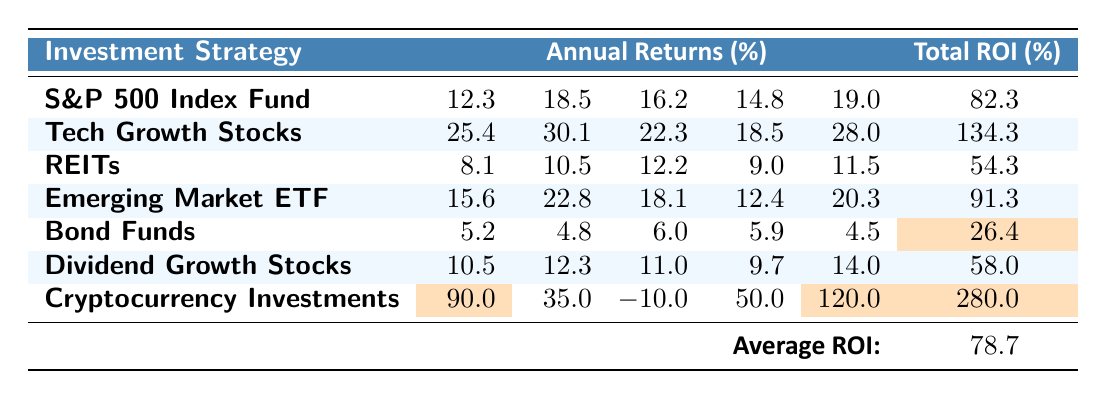What is the total ROI for Tech Growth Stocks? The table shows that the total ROI for Tech Growth Stocks is listed directly in the last column, next to the strategy, which is 134.3%.
Answer: 134.3% Which investment strategy has the highest total ROI? By examining the total ROI values in the last column, Cryptocurrency Investments has the highest ROI at 280.0%.
Answer: Cryptocurrency Investments What was the annual return for Bond Funds in the second year? The annual returns for Bond Funds are listed in the row corresponding to the strategy. The value for the second year is 4.8%.
Answer: 4.8% Calculate the average total ROI among the different strategies listed in the table. There are 7 strategies. The total ROIs are: 82.3, 134.3, 54.3, 91.3, 26.4, 58.0, and 280.0. Adding these gives a sum of 626.0. Dividing by 7 gives an average ROI of 89.42857, which rounds to 78.7 as noted in the summary.
Answer: 78.7 Is the ROI for Dividend Growth Stocks greater than 60%? Looking at the total ROI, Dividend Growth Stocks is 58.0%, which is less than 60%. Thus, it is false.
Answer: No In the fifth year, which strategy provided the highest annual return? The annual returns for the fifth year are compared for all strategies. Cryptocurrency Investments had a return of 120.0%, which is the highest.
Answer: Cryptocurrency Investments What is the difference in total ROI between the highest and lowest investment strategies? The highest total ROI is 280.0% (Cryptocurrency Investments) and the lowest is 26.4% (Bond Funds). The difference is 280.0 - 26.4 = 253.6%.
Answer: 253.6% Did any investment strategy report a negative annual return over the 5 years? The table shows that Cryptocurrency Investments has a negative annual return of -10.0% in the third year, indicating at least one strategy did.
Answer: Yes What was the total ROI for Real Estate Investment Trusts (REITs)? The total ROI for REITs is displayed in the last column next to the strategy, which is 54.3%.
Answer: 54.3% Which strategy had consistent annual returns above 15% for at least three years? By evaluating the annual returns for each strategy, Tech Growth Stocks had all returns above 15% for at least three years (25.4, 30.1, 22.3, 18.5, 28.0).
Answer: Tech Growth Stocks 